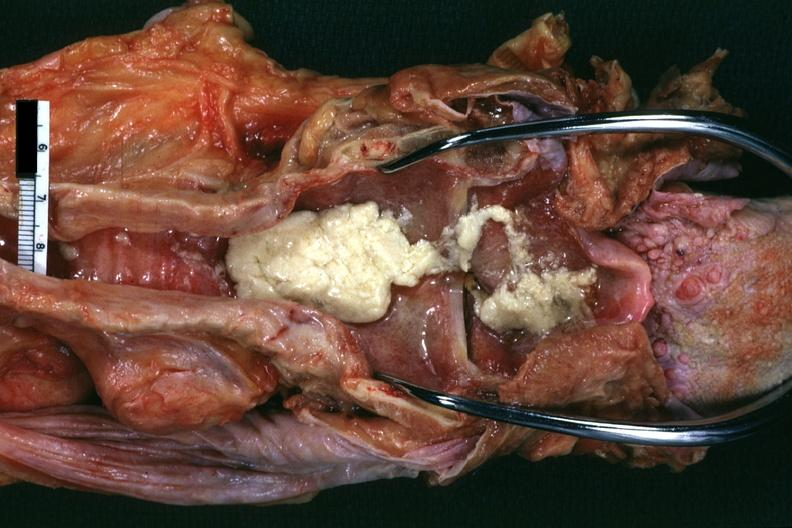s anthracotic pigment present?
Answer the question using a single word or phrase. No 